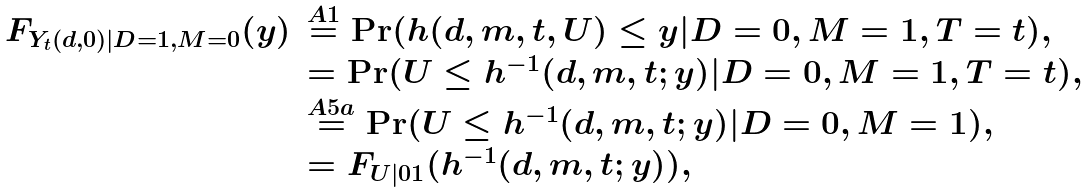Convert formula to latex. <formula><loc_0><loc_0><loc_500><loc_500>\begin{array} { r l } F _ { Y _ { t } ( d , 0 ) | D = 1 , M = 0 } ( y ) & \stackrel { A 1 } { = } \Pr ( h ( d , m , t , U ) \leq y | D = 0 , M = 1 , T = t ) , \\ & = \Pr ( U \leq h ^ { - 1 } ( d , m , t ; y ) | D = 0 , M = 1 , T = t ) , \\ & \stackrel { A 5 a } { = } \Pr ( U \leq h ^ { - 1 } ( d , m , t ; y ) | D = 0 , M = 1 ) , \\ & = F _ { U | 0 1 } ( h ^ { - 1 } ( d , m , t ; y ) ) , \end{array}</formula> 